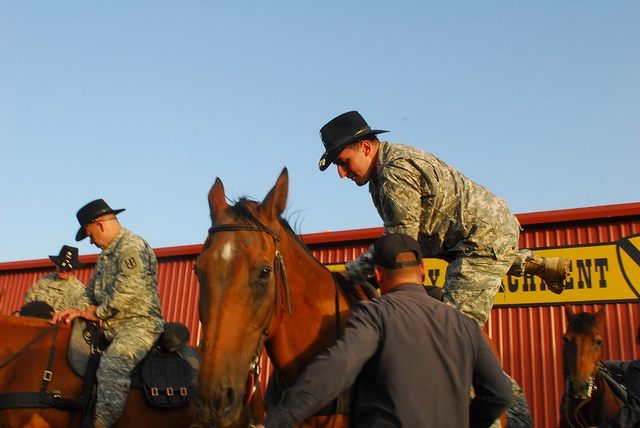Describe the objects in this image and their specific colors. I can see horse in lightblue, maroon, black, and brown tones, people in lightblue, black, maroon, and brown tones, people in lightblue, black, tan, and olive tones, horse in lightblue, black, maroon, and olive tones, and people in lightblue, tan, black, gray, and olive tones in this image. 